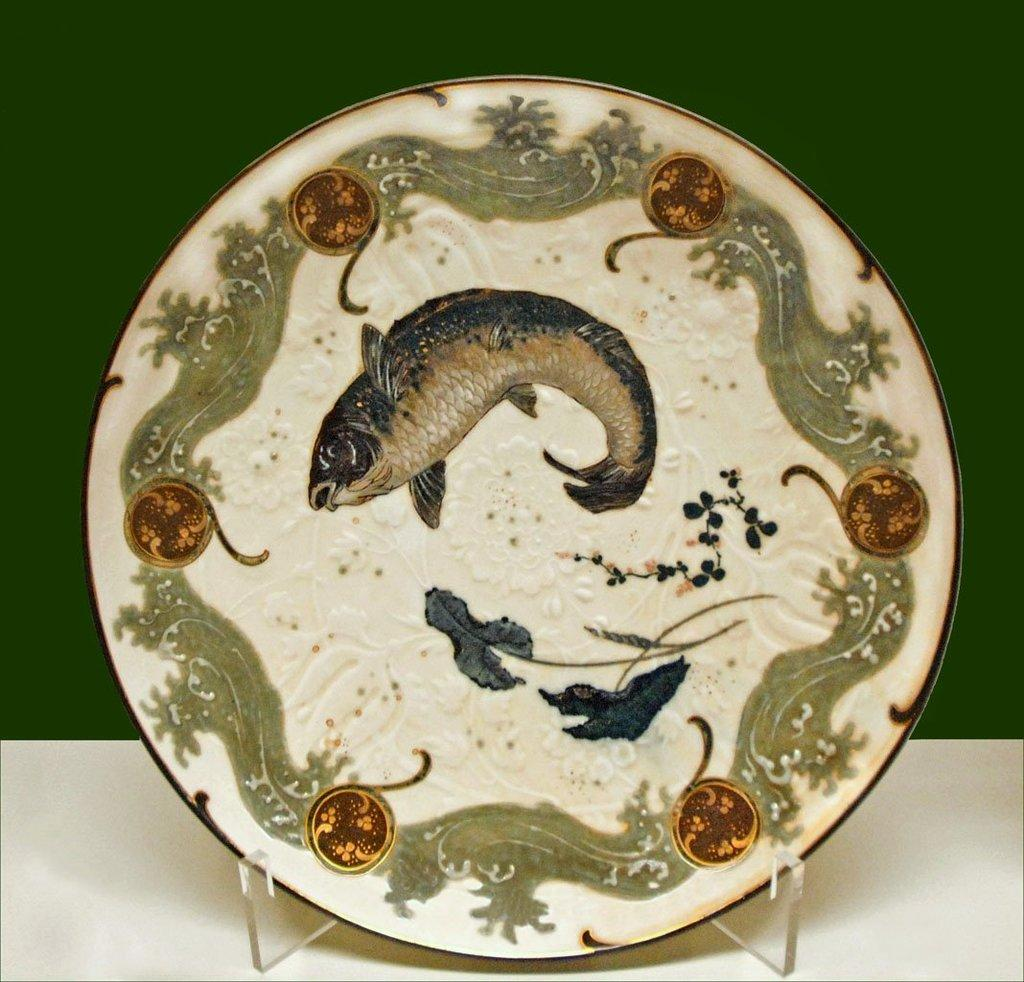What is depicted on the plate in the image? There are paintings of a fish on a plate and paintings of leaves on the plate. Are there any other designs on the plate? Yes, there are other designs on the plate. What color is the plate in the image? The plate is white in color. What color is the background of the image? The background of the image is green in color. How does the hen feel about the designs on the plate in the image? There is no hen present in the image, so it is not possible to determine how a hen might feel about the designs on the plate. 